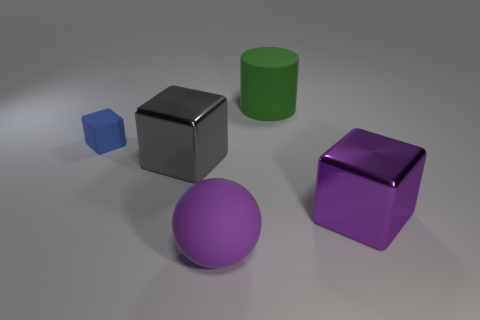There is a metallic object that is the same color as the sphere; what shape is it?
Ensure brevity in your answer.  Cube. Does the small block have the same color as the cylinder?
Offer a very short reply. No. What number of things are either small things or large blocks right of the gray metallic cube?
Your response must be concise. 2. Are there any cyan shiny cylinders that have the same size as the purple matte thing?
Make the answer very short. No. Is the big gray block made of the same material as the small object?
Provide a succinct answer. No. What number of things are big green cylinders or purple shiny things?
Your answer should be compact. 2. What is the size of the blue rubber thing?
Your answer should be very brief. Small. Is the number of large rubber cylinders less than the number of things?
Ensure brevity in your answer.  Yes. What number of big metal things are the same color as the large rubber sphere?
Ensure brevity in your answer.  1. There is a big metallic block that is right of the gray thing; does it have the same color as the large ball?
Offer a very short reply. Yes. 